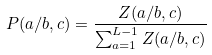<formula> <loc_0><loc_0><loc_500><loc_500>P ( a / b , c ) = \frac { Z ( a / b , c ) } { \sum _ { a = 1 } ^ { L - 1 } Z ( a / b , c ) }</formula> 